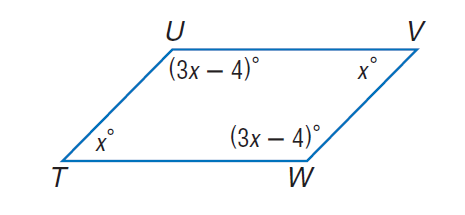Question: Find \angle W.
Choices:
A. 44
B. 46
C. 54
D. 134
Answer with the letter. Answer: D Question: Find \angle V.
Choices:
A. 44
B. 46
C. 54
D. 134
Answer with the letter. Answer: B Question: Find m \angle T.
Choices:
A. 44
B. 46
C. 54
D. 134
Answer with the letter. Answer: B Question: Find m \angle U.
Choices:
A. 44
B. 46
C. 54
D. 134
Answer with the letter. Answer: D 